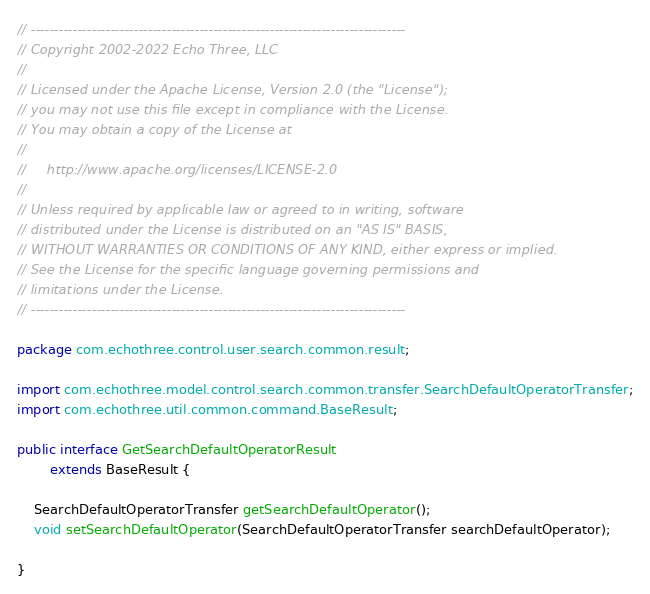Convert code to text. <code><loc_0><loc_0><loc_500><loc_500><_Java_>// --------------------------------------------------------------------------------
// Copyright 2002-2022 Echo Three, LLC
//
// Licensed under the Apache License, Version 2.0 (the "License");
// you may not use this file except in compliance with the License.
// You may obtain a copy of the License at
//
//     http://www.apache.org/licenses/LICENSE-2.0
//
// Unless required by applicable law or agreed to in writing, software
// distributed under the License is distributed on an "AS IS" BASIS,
// WITHOUT WARRANTIES OR CONDITIONS OF ANY KIND, either express or implied.
// See the License for the specific language governing permissions and
// limitations under the License.
// --------------------------------------------------------------------------------

package com.echothree.control.user.search.common.result;

import com.echothree.model.control.search.common.transfer.SearchDefaultOperatorTransfer;
import com.echothree.util.common.command.BaseResult;

public interface GetSearchDefaultOperatorResult
        extends BaseResult {
    
    SearchDefaultOperatorTransfer getSearchDefaultOperator();
    void setSearchDefaultOperator(SearchDefaultOperatorTransfer searchDefaultOperator);
    
}
</code> 